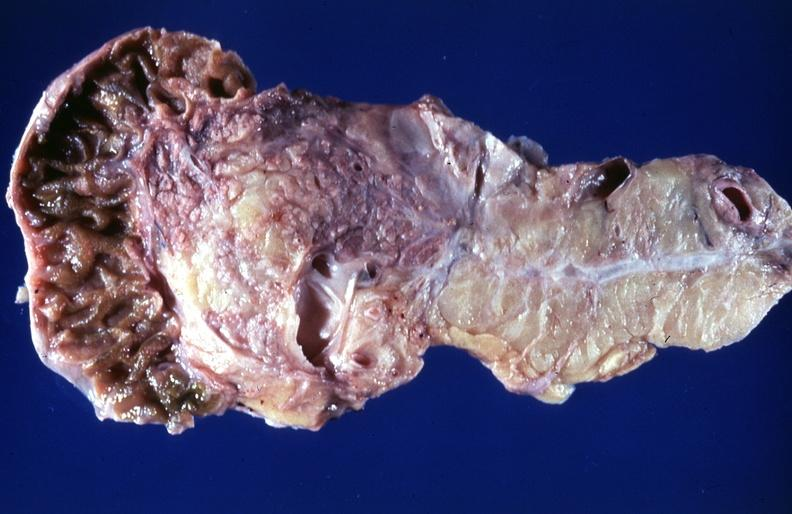does serous cyst show cystic fibrosis?
Answer the question using a single word or phrase. No 